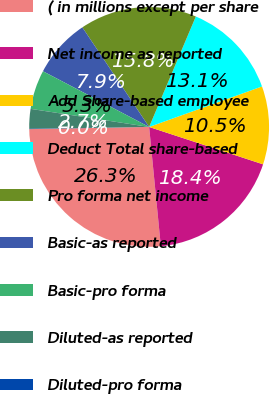Convert chart. <chart><loc_0><loc_0><loc_500><loc_500><pie_chart><fcel>( in millions except per share<fcel>Net income as reported<fcel>Add Share-based employee<fcel>Deduct Total share-based<fcel>Pro forma net income<fcel>Basic-as reported<fcel>Basic-pro forma<fcel>Diluted-as reported<fcel>Diluted-pro forma<nl><fcel>26.27%<fcel>18.4%<fcel>10.53%<fcel>13.15%<fcel>15.77%<fcel>7.91%<fcel>5.28%<fcel>2.66%<fcel>0.04%<nl></chart> 